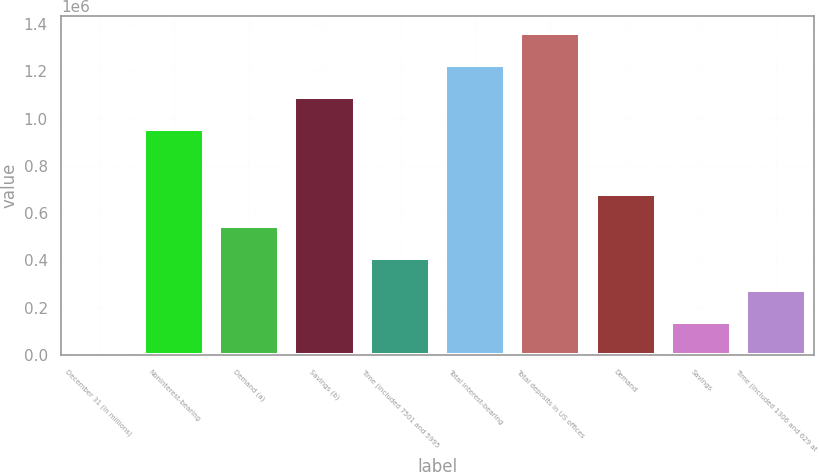Convert chart to OTSL. <chart><loc_0><loc_0><loc_500><loc_500><bar_chart><fcel>December 31 (in millions)<fcel>Noninterest-bearing<fcel>Demand (a)<fcel>Savings (b)<fcel>Time (included 7501 and 5995<fcel>Total interest-bearing<fcel>Total deposits in US offices<fcel>Demand<fcel>Savings<fcel>Time (included 1306 and 629 at<nl><fcel>2014<fcel>955003<fcel>546579<fcel>1.09114e+06<fcel>410438<fcel>1.22729e+06<fcel>1.36343e+06<fcel>682720<fcel>138155<fcel>274297<nl></chart> 